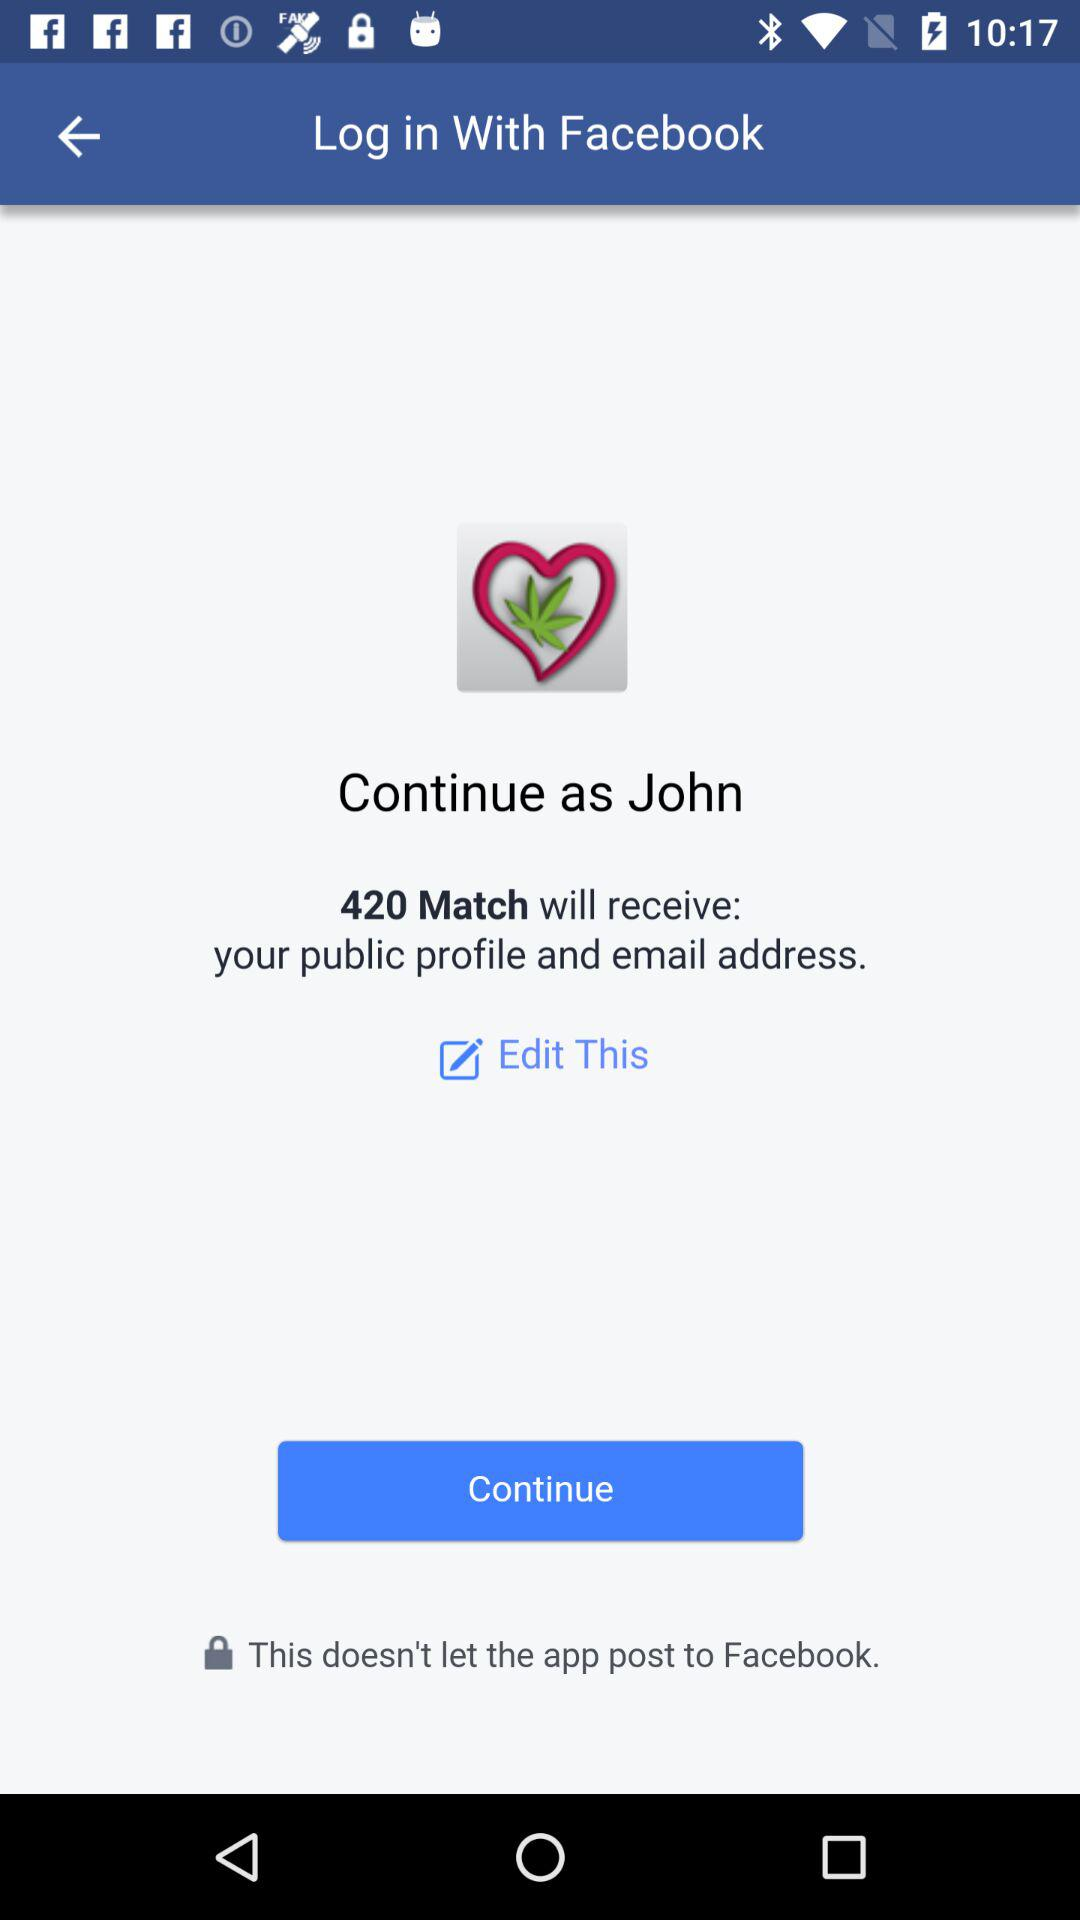What application is asking for permission? The application is "420 Match". 